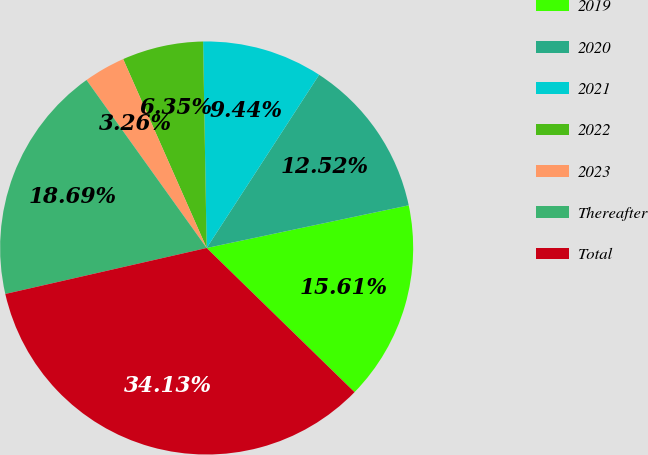Convert chart to OTSL. <chart><loc_0><loc_0><loc_500><loc_500><pie_chart><fcel>2019<fcel>2020<fcel>2021<fcel>2022<fcel>2023<fcel>Thereafter<fcel>Total<nl><fcel>15.61%<fcel>12.52%<fcel>9.44%<fcel>6.35%<fcel>3.26%<fcel>18.69%<fcel>34.13%<nl></chart> 